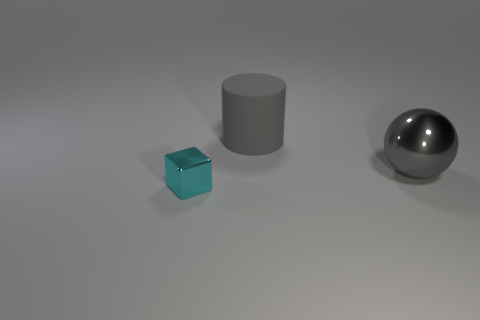How are the shadows of the objects in the image interacting? The objects cast shadows that slightly overlap, suggesting a light source positioned above and to the side, creating a sense of depth and dimension in the scene. 